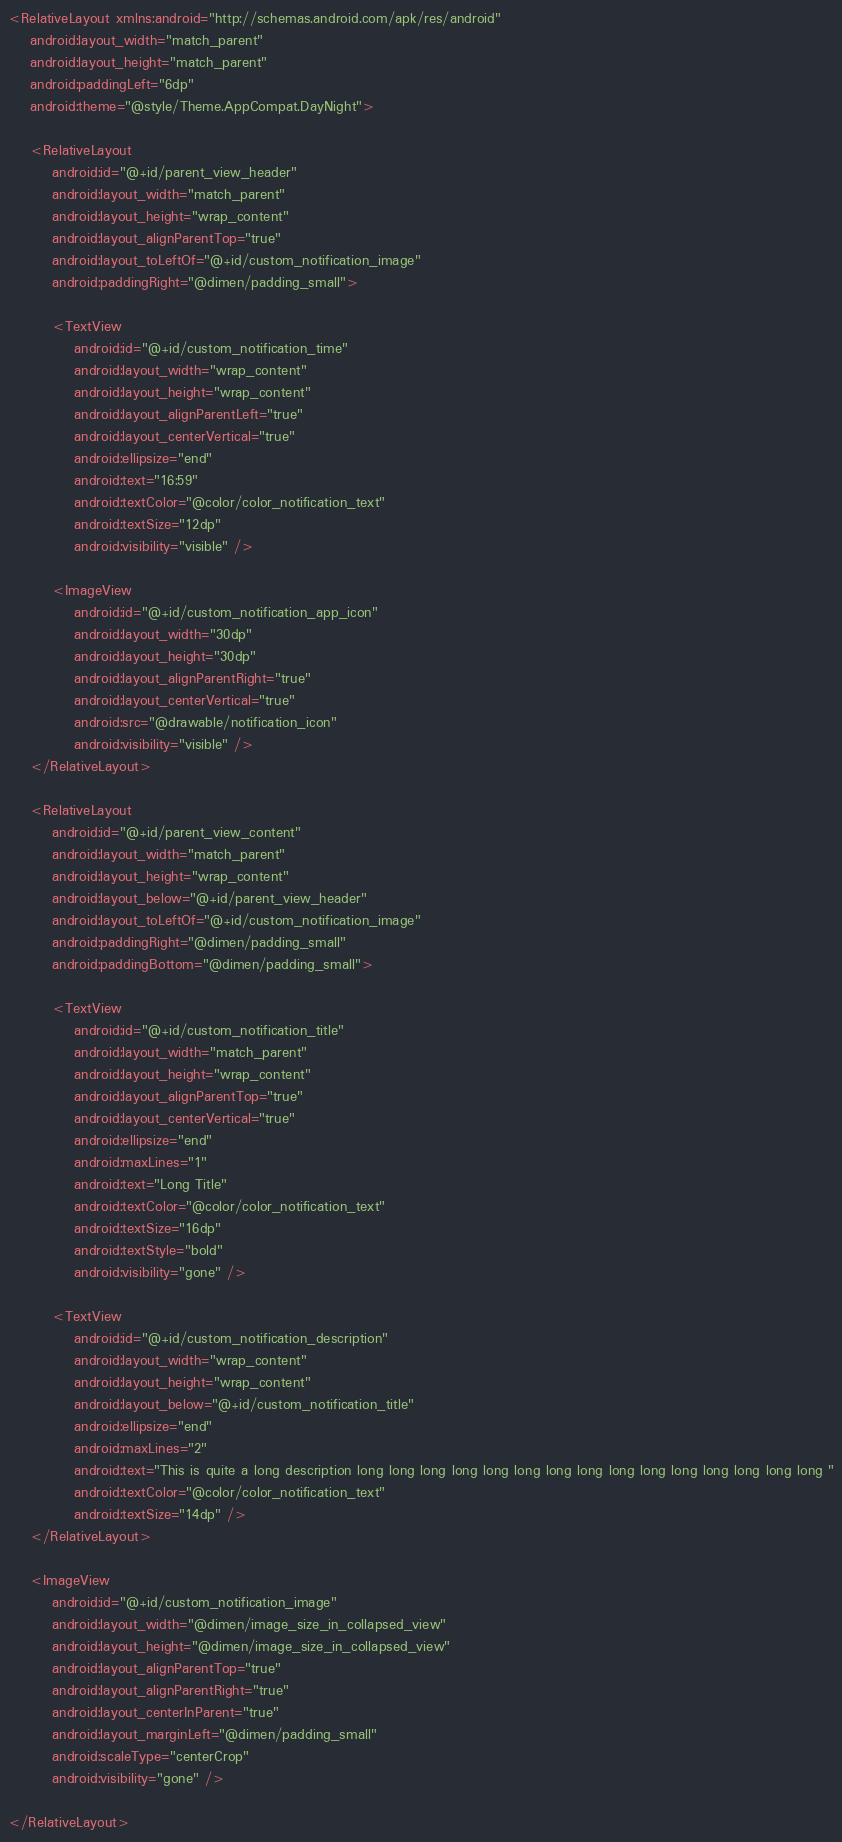Convert code to text. <code><loc_0><loc_0><loc_500><loc_500><_XML_><RelativeLayout xmlns:android="http://schemas.android.com/apk/res/android"
    android:layout_width="match_parent"
    android:layout_height="match_parent"
    android:paddingLeft="6dp"
    android:theme="@style/Theme.AppCompat.DayNight">

    <RelativeLayout
        android:id="@+id/parent_view_header"
        android:layout_width="match_parent"
        android:layout_height="wrap_content"
        android:layout_alignParentTop="true"
        android:layout_toLeftOf="@+id/custom_notification_image"
        android:paddingRight="@dimen/padding_small">

        <TextView
            android:id="@+id/custom_notification_time"
            android:layout_width="wrap_content"
            android:layout_height="wrap_content"
            android:layout_alignParentLeft="true"
            android:layout_centerVertical="true"
            android:ellipsize="end"
            android:text="16:59"
            android:textColor="@color/color_notification_text"
            android:textSize="12dp"
            android:visibility="visible" />

        <ImageView
            android:id="@+id/custom_notification_app_icon"
            android:layout_width="30dp"
            android:layout_height="30dp"
            android:layout_alignParentRight="true"
            android:layout_centerVertical="true"
            android:src="@drawable/notification_icon"
            android:visibility="visible" />
    </RelativeLayout>

    <RelativeLayout
        android:id="@+id/parent_view_content"
        android:layout_width="match_parent"
        android:layout_height="wrap_content"
        android:layout_below="@+id/parent_view_header"
        android:layout_toLeftOf="@+id/custom_notification_image"
        android:paddingRight="@dimen/padding_small"
        android:paddingBottom="@dimen/padding_small">

        <TextView
            android:id="@+id/custom_notification_title"
            android:layout_width="match_parent"
            android:layout_height="wrap_content"
            android:layout_alignParentTop="true"
            android:layout_centerVertical="true"
            android:ellipsize="end"
            android:maxLines="1"
            android:text="Long Title"
            android:textColor="@color/color_notification_text"
            android:textSize="16dp"
            android:textStyle="bold"
            android:visibility="gone" />

        <TextView
            android:id="@+id/custom_notification_description"
            android:layout_width="wrap_content"
            android:layout_height="wrap_content"
            android:layout_below="@+id/custom_notification_title"
            android:ellipsize="end"
            android:maxLines="2"
            android:text="This is quite a long description long long long long long long long long long long long long long long long "
            android:textColor="@color/color_notification_text"
            android:textSize="14dp" />
    </RelativeLayout>

    <ImageView
        android:id="@+id/custom_notification_image"
        android:layout_width="@dimen/image_size_in_collapsed_view"
        android:layout_height="@dimen/image_size_in_collapsed_view"
        android:layout_alignParentTop="true"
        android:layout_alignParentRight="true"
        android:layout_centerInParent="true"
        android:layout_marginLeft="@dimen/padding_small"
        android:scaleType="centerCrop"
        android:visibility="gone" />

</RelativeLayout></code> 